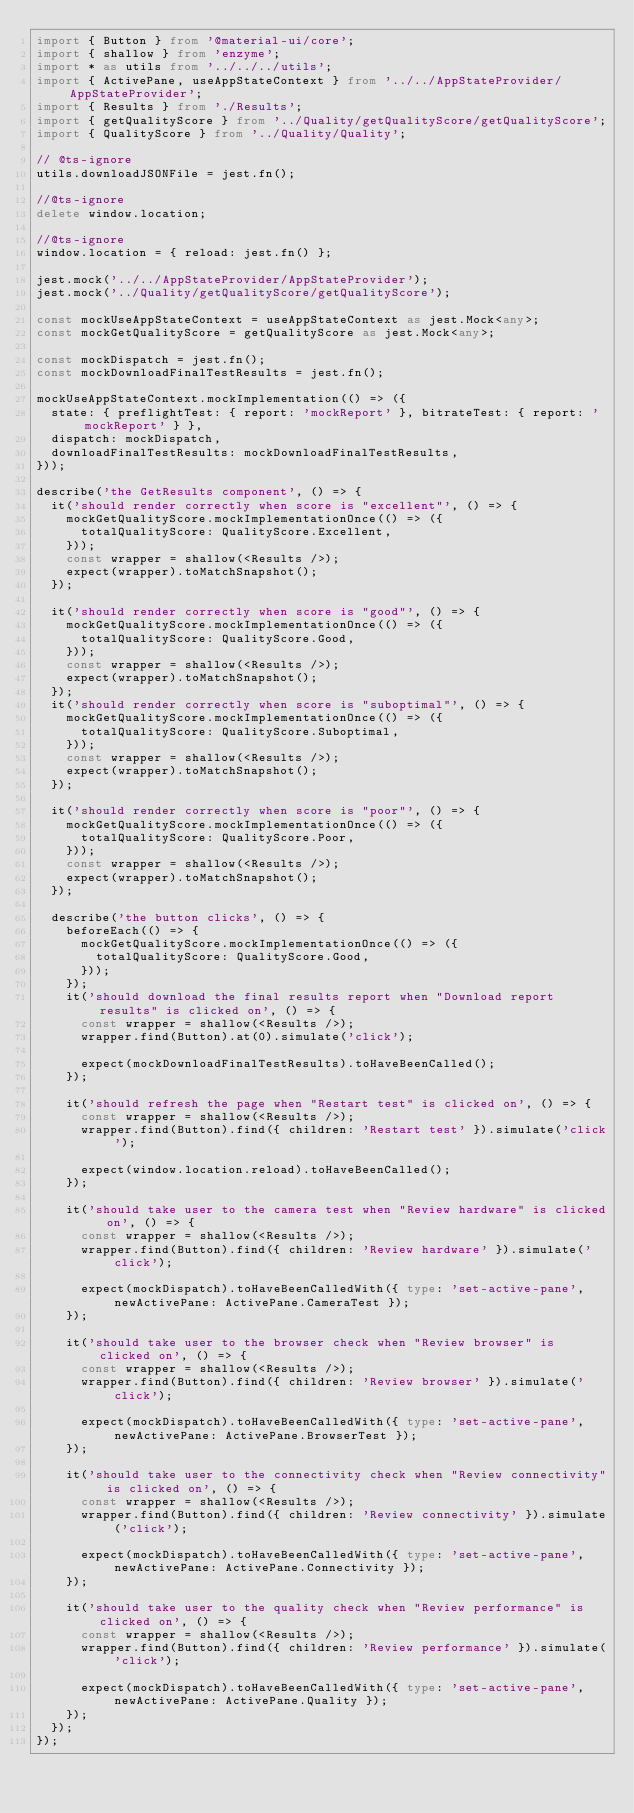<code> <loc_0><loc_0><loc_500><loc_500><_TypeScript_>import { Button } from '@material-ui/core';
import { shallow } from 'enzyme';
import * as utils from '../../../utils';
import { ActivePane, useAppStateContext } from '../../AppStateProvider/AppStateProvider';
import { Results } from './Results';
import { getQualityScore } from '../Quality/getQualityScore/getQualityScore';
import { QualityScore } from '../Quality/Quality';

// @ts-ignore
utils.downloadJSONFile = jest.fn();

//@ts-ignore
delete window.location;

//@ts-ignore
window.location = { reload: jest.fn() };

jest.mock('../../AppStateProvider/AppStateProvider');
jest.mock('../Quality/getQualityScore/getQualityScore');

const mockUseAppStateContext = useAppStateContext as jest.Mock<any>;
const mockGetQualityScore = getQualityScore as jest.Mock<any>;

const mockDispatch = jest.fn();
const mockDownloadFinalTestResults = jest.fn();

mockUseAppStateContext.mockImplementation(() => ({
  state: { preflightTest: { report: 'mockReport' }, bitrateTest: { report: 'mockReport' } },
  dispatch: mockDispatch,
  downloadFinalTestResults: mockDownloadFinalTestResults,
}));

describe('the GetResults component', () => {
  it('should render correctly when score is "excellent"', () => {
    mockGetQualityScore.mockImplementationOnce(() => ({
      totalQualityScore: QualityScore.Excellent,
    }));
    const wrapper = shallow(<Results />);
    expect(wrapper).toMatchSnapshot();
  });

  it('should render correctly when score is "good"', () => {
    mockGetQualityScore.mockImplementationOnce(() => ({
      totalQualityScore: QualityScore.Good,
    }));
    const wrapper = shallow(<Results />);
    expect(wrapper).toMatchSnapshot();
  });
  it('should render correctly when score is "suboptimal"', () => {
    mockGetQualityScore.mockImplementationOnce(() => ({
      totalQualityScore: QualityScore.Suboptimal,
    }));
    const wrapper = shallow(<Results />);
    expect(wrapper).toMatchSnapshot();
  });

  it('should render correctly when score is "poor"', () => {
    mockGetQualityScore.mockImplementationOnce(() => ({
      totalQualityScore: QualityScore.Poor,
    }));
    const wrapper = shallow(<Results />);
    expect(wrapper).toMatchSnapshot();
  });

  describe('the button clicks', () => {
    beforeEach(() => {
      mockGetQualityScore.mockImplementationOnce(() => ({
        totalQualityScore: QualityScore.Good,
      }));
    });
    it('should download the final results report when "Download report results" is clicked on', () => {
      const wrapper = shallow(<Results />);
      wrapper.find(Button).at(0).simulate('click');

      expect(mockDownloadFinalTestResults).toHaveBeenCalled();
    });

    it('should refresh the page when "Restart test" is clicked on', () => {
      const wrapper = shallow(<Results />);
      wrapper.find(Button).find({ children: 'Restart test' }).simulate('click');

      expect(window.location.reload).toHaveBeenCalled();
    });

    it('should take user to the camera test when "Review hardware" is clicked on', () => {
      const wrapper = shallow(<Results />);
      wrapper.find(Button).find({ children: 'Review hardware' }).simulate('click');

      expect(mockDispatch).toHaveBeenCalledWith({ type: 'set-active-pane', newActivePane: ActivePane.CameraTest });
    });

    it('should take user to the browser check when "Review browser" is clicked on', () => {
      const wrapper = shallow(<Results />);
      wrapper.find(Button).find({ children: 'Review browser' }).simulate('click');

      expect(mockDispatch).toHaveBeenCalledWith({ type: 'set-active-pane', newActivePane: ActivePane.BrowserTest });
    });

    it('should take user to the connectivity check when "Review connectivity" is clicked on', () => {
      const wrapper = shallow(<Results />);
      wrapper.find(Button).find({ children: 'Review connectivity' }).simulate('click');

      expect(mockDispatch).toHaveBeenCalledWith({ type: 'set-active-pane', newActivePane: ActivePane.Connectivity });
    });

    it('should take user to the quality check when "Review performance" is clicked on', () => {
      const wrapper = shallow(<Results />);
      wrapper.find(Button).find({ children: 'Review performance' }).simulate('click');

      expect(mockDispatch).toHaveBeenCalledWith({ type: 'set-active-pane', newActivePane: ActivePane.Quality });
    });
  });
});
</code> 